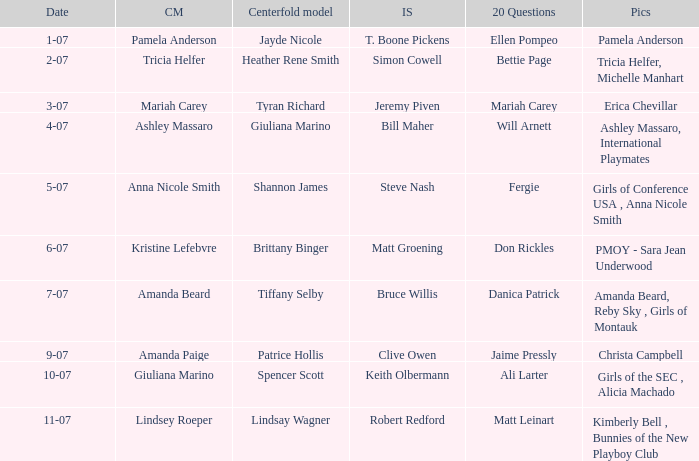Who answered the 20 questions on 10-07? Ali Larter. 